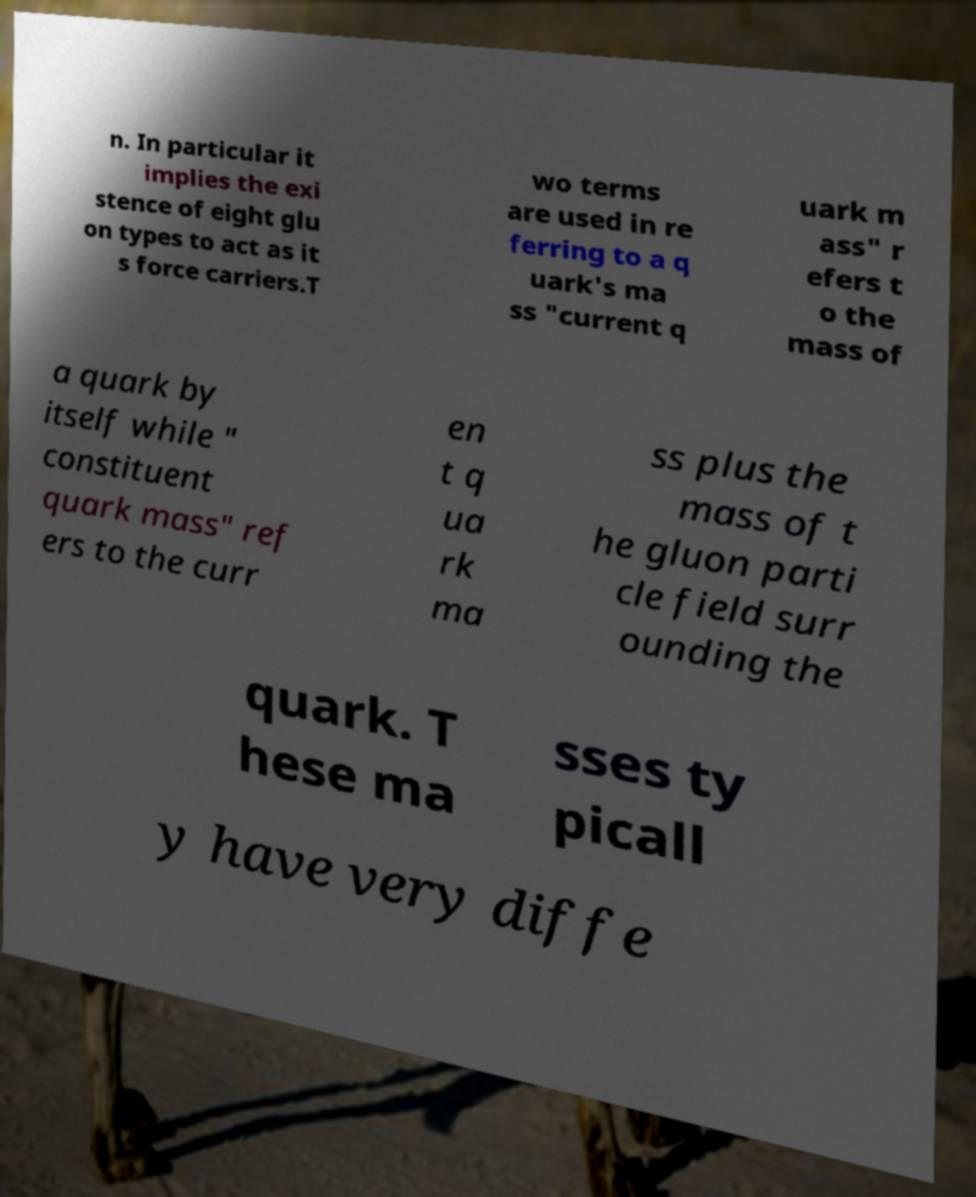Could you assist in decoding the text presented in this image and type it out clearly? n. In particular it implies the exi stence of eight glu on types to act as it s force carriers.T wo terms are used in re ferring to a q uark's ma ss "current q uark m ass" r efers t o the mass of a quark by itself while " constituent quark mass" ref ers to the curr en t q ua rk ma ss plus the mass of t he gluon parti cle field surr ounding the quark. T hese ma sses ty picall y have very diffe 